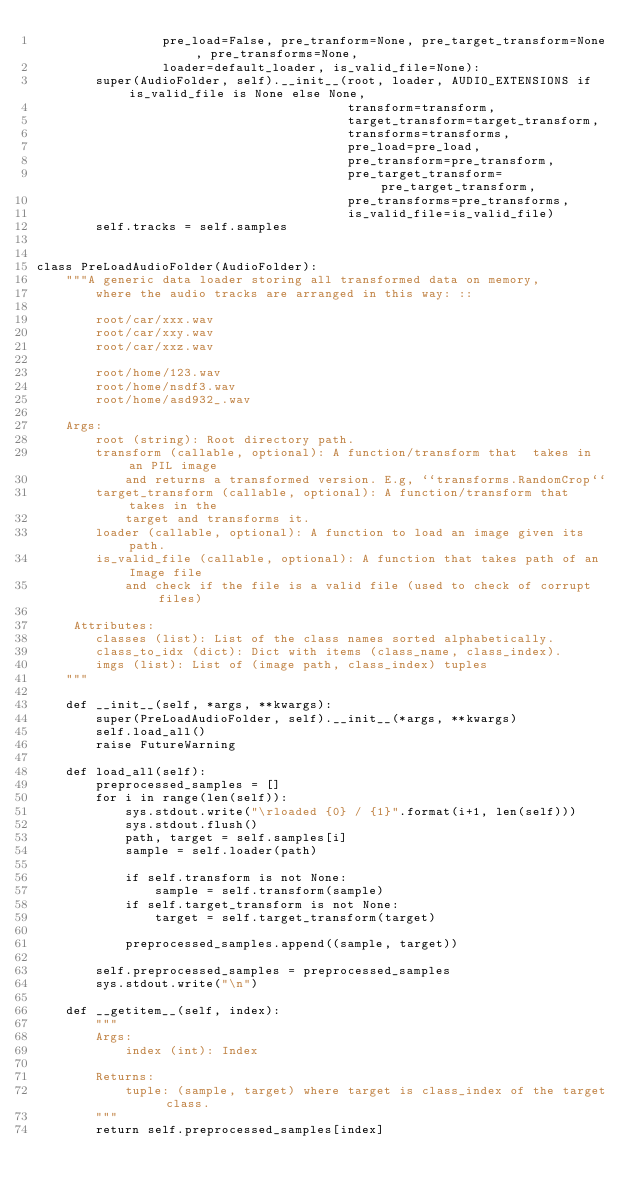Convert code to text. <code><loc_0><loc_0><loc_500><loc_500><_Python_>                 pre_load=False, pre_tranform=None, pre_target_transform=None, pre_transforms=None,
                 loader=default_loader, is_valid_file=None):
        super(AudioFolder, self).__init__(root, loader, AUDIO_EXTENSIONS if is_valid_file is None else None,
                                          transform=transform,
                                          target_transform=target_transform,
                                          transforms=transforms,
                                          pre_load=pre_load,
                                          pre_transform=pre_transform,
                                          pre_target_transform=pre_target_transform,
                                          pre_transforms=pre_transforms,
                                          is_valid_file=is_valid_file)
        self.tracks = self.samples
    

class PreLoadAudioFolder(AudioFolder):
    """A generic data loader storing all transformed data on memory,
        where the audio tracks are arranged in this way: ::

        root/car/xxx.wav
        root/car/xxy.wav
        root/car/xxz.wav

        root/home/123.wav
        root/home/nsdf3.wav
        root/home/asd932_.wav

    Args:
        root (string): Root directory path.
        transform (callable, optional): A function/transform that  takes in an PIL image
            and returns a transformed version. E.g, ``transforms.RandomCrop``
        target_transform (callable, optional): A function/transform that takes in the
            target and transforms it.
        loader (callable, optional): A function to load an image given its path.
        is_valid_file (callable, optional): A function that takes path of an Image file
            and check if the file is a valid file (used to check of corrupt files)

     Attributes:
        classes (list): List of the class names sorted alphabetically.
        class_to_idx (dict): Dict with items (class_name, class_index).
        imgs (list): List of (image path, class_index) tuples
    """

    def __init__(self, *args, **kwargs):
        super(PreLoadAudioFolder, self).__init__(*args, **kwargs)
        self.load_all()
        raise FutureWarning
    
    def load_all(self):
        preprocessed_samples = []
        for i in range(len(self)):
            sys.stdout.write("\rloaded {0} / {1}".format(i+1, len(self)))
            sys.stdout.flush()
            path, target = self.samples[i]
            sample = self.loader(path)

            if self.transform is not None:
                sample = self.transform(sample)
            if self.target_transform is not None:
                target = self.target_transform(target)

            preprocessed_samples.append((sample, target))

        self.preprocessed_samples = preprocessed_samples
        sys.stdout.write("\n")

    def __getitem__(self, index):
        """
        Args:
            index (int): Index

        Returns:
            tuple: (sample, target) where target is class_index of the target class.
        """
        return self.preprocessed_samples[index]</code> 